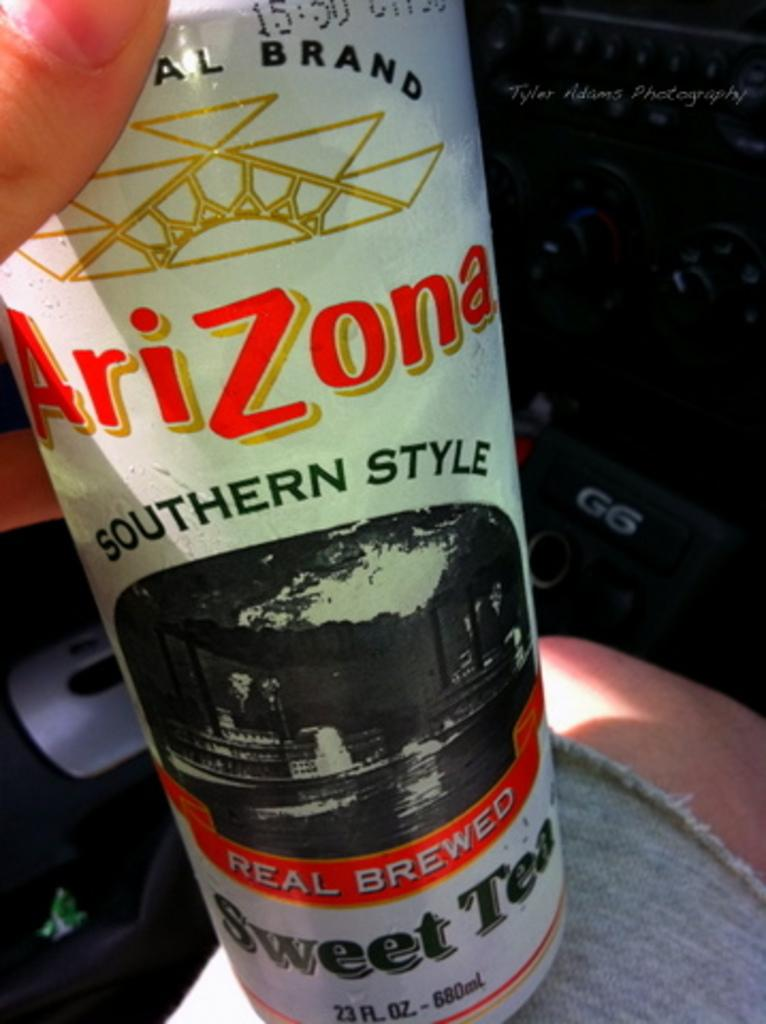<image>
Write a terse but informative summary of the picture. A can of Arizona Southern style sweet tea in orange and white. 